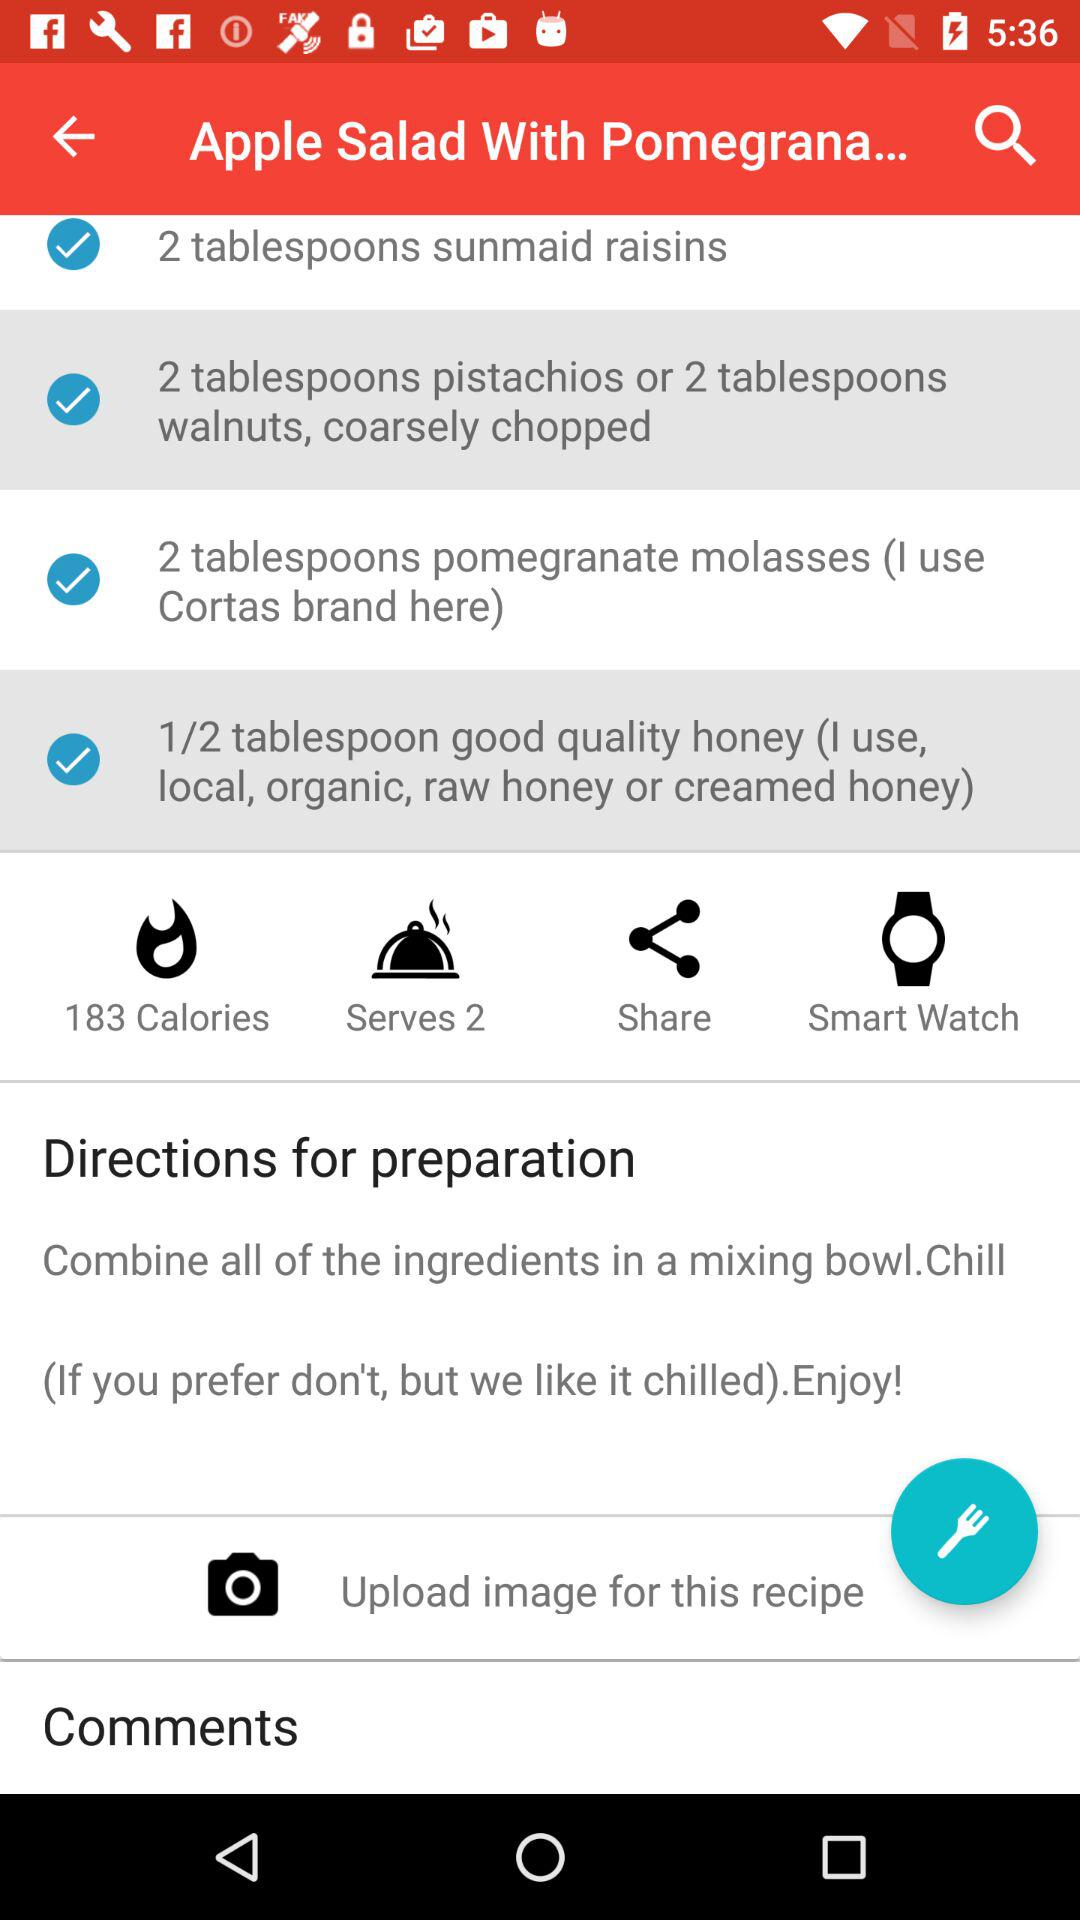How many calories are in this recipe?
Answer the question using a single word or phrase. 183 